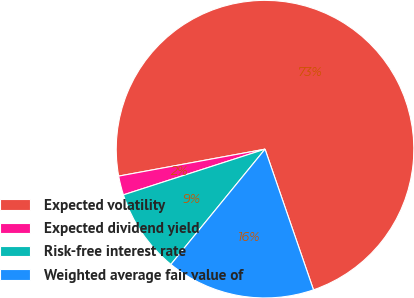Convert chart. <chart><loc_0><loc_0><loc_500><loc_500><pie_chart><fcel>Expected volatility<fcel>Expected dividend yield<fcel>Risk-free interest rate<fcel>Weighted average fair value of<nl><fcel>72.61%<fcel>2.07%<fcel>9.13%<fcel>16.18%<nl></chart> 